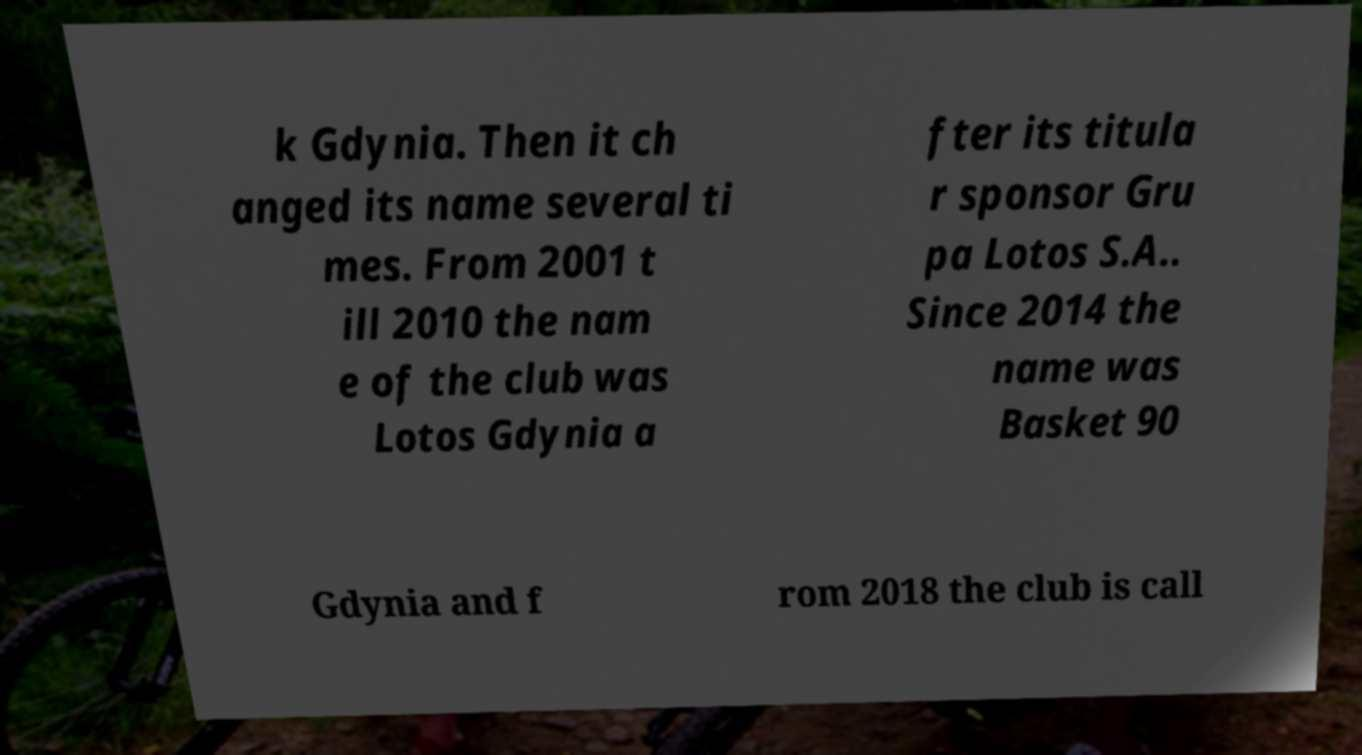Can you accurately transcribe the text from the provided image for me? k Gdynia. Then it ch anged its name several ti mes. From 2001 t ill 2010 the nam e of the club was Lotos Gdynia a fter its titula r sponsor Gru pa Lotos S.A.. Since 2014 the name was Basket 90 Gdynia and f rom 2018 the club is call 